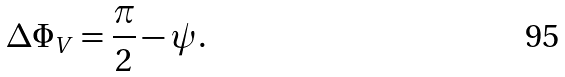Convert formula to latex. <formula><loc_0><loc_0><loc_500><loc_500>\Delta \Phi _ { V } = \frac { \pi } { 2 } - \psi .</formula> 